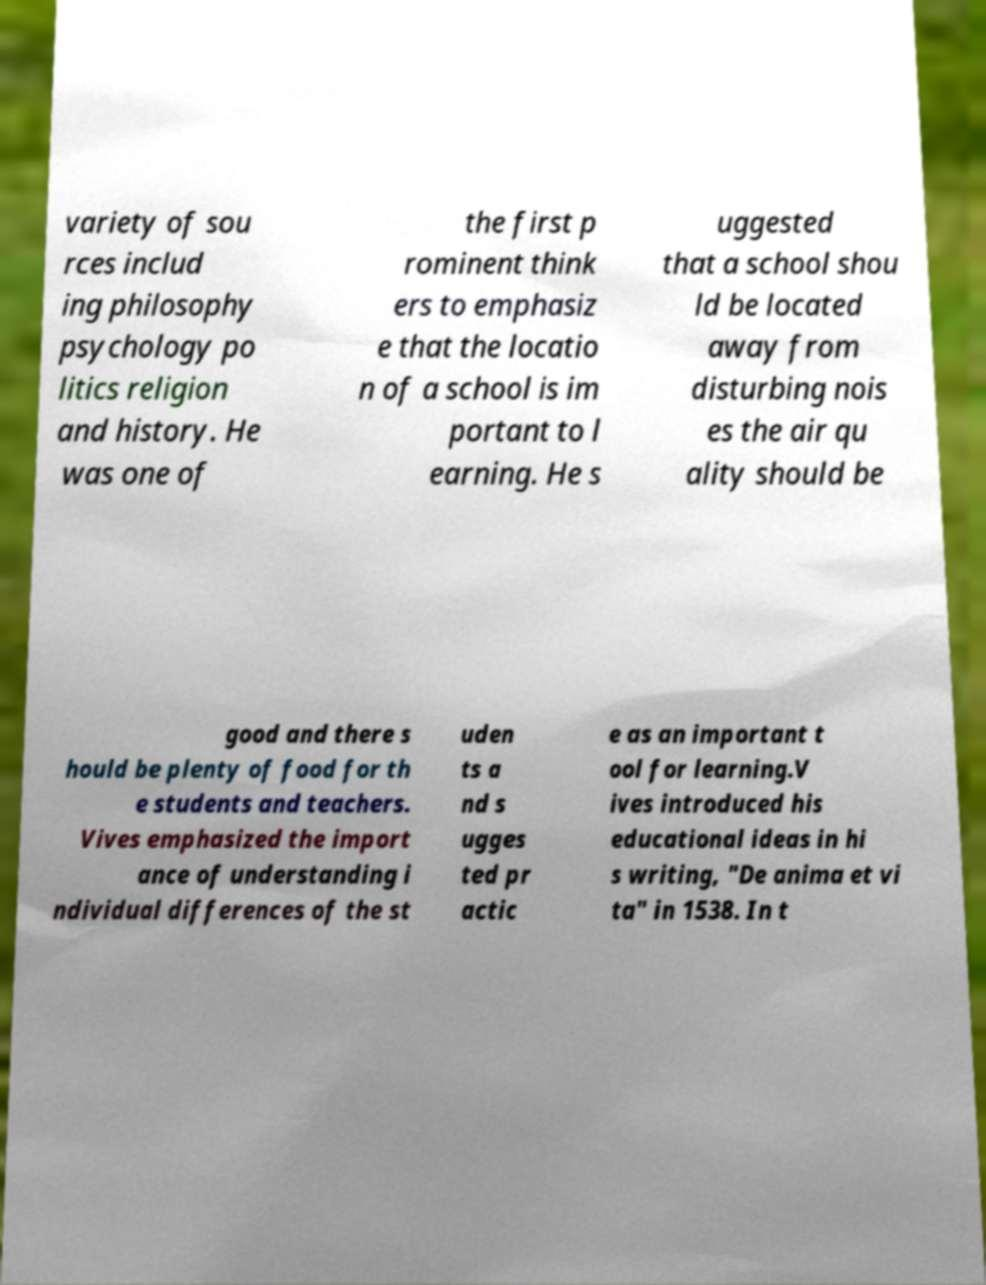Can you accurately transcribe the text from the provided image for me? variety of sou rces includ ing philosophy psychology po litics religion and history. He was one of the first p rominent think ers to emphasiz e that the locatio n of a school is im portant to l earning. He s uggested that a school shou ld be located away from disturbing nois es the air qu ality should be good and there s hould be plenty of food for th e students and teachers. Vives emphasized the import ance of understanding i ndividual differences of the st uden ts a nd s ugges ted pr actic e as an important t ool for learning.V ives introduced his educational ideas in hi s writing, "De anima et vi ta" in 1538. In t 